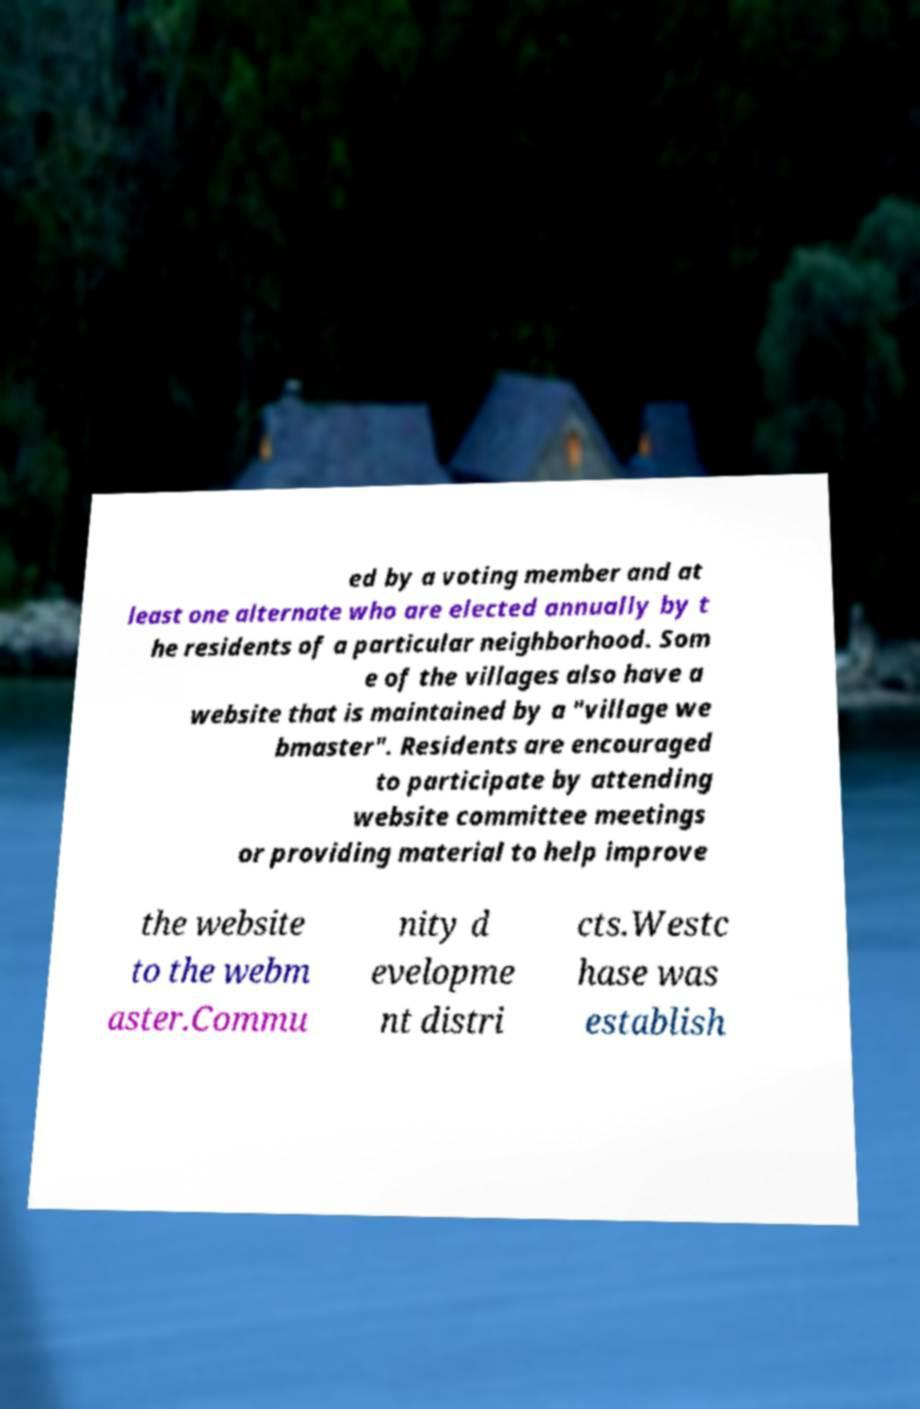Could you assist in decoding the text presented in this image and type it out clearly? ed by a voting member and at least one alternate who are elected annually by t he residents of a particular neighborhood. Som e of the villages also have a website that is maintained by a "village we bmaster". Residents are encouraged to participate by attending website committee meetings or providing material to help improve the website to the webm aster.Commu nity d evelopme nt distri cts.Westc hase was establish 